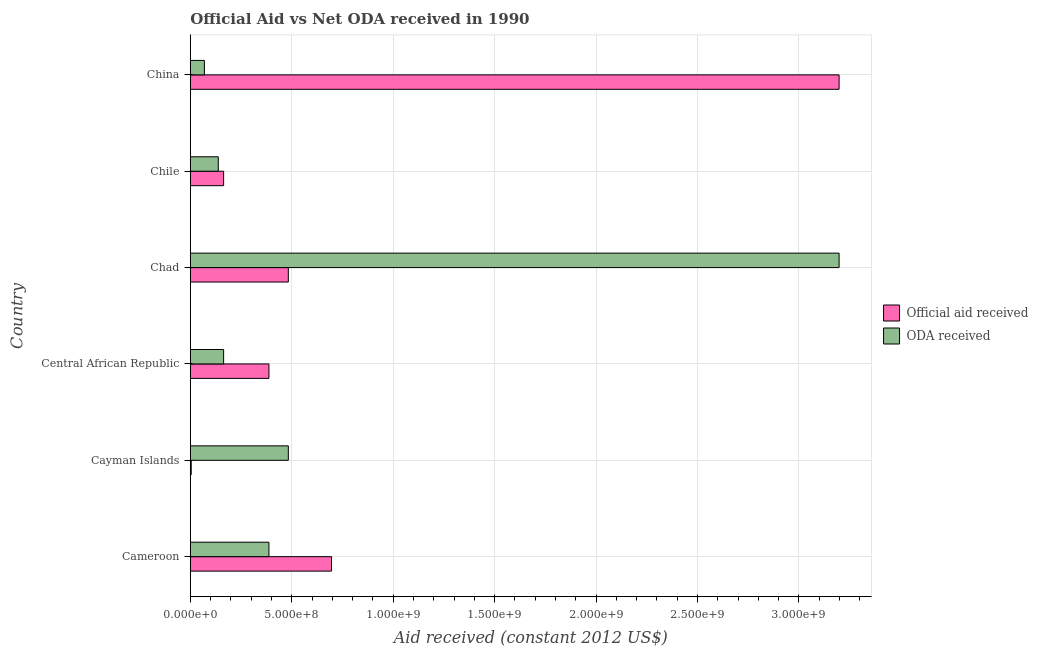Are the number of bars on each tick of the Y-axis equal?
Offer a very short reply. Yes. What is the label of the 5th group of bars from the top?
Your response must be concise. Cayman Islands. What is the official aid received in Cayman Islands?
Make the answer very short. 4.58e+06. Across all countries, what is the maximum oda received?
Your response must be concise. 3.20e+09. Across all countries, what is the minimum official aid received?
Ensure brevity in your answer.  4.58e+06. In which country was the official aid received minimum?
Keep it short and to the point. Cayman Islands. What is the total official aid received in the graph?
Ensure brevity in your answer.  4.93e+09. What is the difference between the official aid received in Cayman Islands and that in Chile?
Offer a very short reply. -1.60e+08. What is the average oda received per country?
Offer a terse response. 7.40e+08. What is the difference between the official aid received and oda received in Cameroon?
Ensure brevity in your answer.  3.09e+08. What is the ratio of the official aid received in Cameroon to that in Chad?
Offer a terse response. 1.44. Is the official aid received in Central African Republic less than that in Chad?
Keep it short and to the point. Yes. Is the difference between the oda received in Cameroon and Cayman Islands greater than the difference between the official aid received in Cameroon and Cayman Islands?
Ensure brevity in your answer.  No. What is the difference between the highest and the second highest official aid received?
Make the answer very short. 2.50e+09. What is the difference between the highest and the lowest official aid received?
Your response must be concise. 3.19e+09. Is the sum of the oda received in Central African Republic and Chad greater than the maximum official aid received across all countries?
Ensure brevity in your answer.  Yes. What does the 2nd bar from the top in Cayman Islands represents?
Keep it short and to the point. Official aid received. What does the 1st bar from the bottom in China represents?
Give a very brief answer. Official aid received. Are the values on the major ticks of X-axis written in scientific E-notation?
Your answer should be compact. Yes. Where does the legend appear in the graph?
Your answer should be compact. Center right. How are the legend labels stacked?
Keep it short and to the point. Vertical. What is the title of the graph?
Provide a short and direct response. Official Aid vs Net ODA received in 1990 . Does "Ages 15-24" appear as one of the legend labels in the graph?
Your response must be concise. No. What is the label or title of the X-axis?
Make the answer very short. Aid received (constant 2012 US$). What is the Aid received (constant 2012 US$) in Official aid received in Cameroon?
Ensure brevity in your answer.  6.96e+08. What is the Aid received (constant 2012 US$) of ODA received in Cameroon?
Provide a short and direct response. 3.88e+08. What is the Aid received (constant 2012 US$) in Official aid received in Cayman Islands?
Make the answer very short. 4.58e+06. What is the Aid received (constant 2012 US$) of ODA received in Cayman Islands?
Provide a short and direct response. 4.83e+08. What is the Aid received (constant 2012 US$) of Official aid received in Central African Republic?
Keep it short and to the point. 3.88e+08. What is the Aid received (constant 2012 US$) in ODA received in Central African Republic?
Ensure brevity in your answer.  1.64e+08. What is the Aid received (constant 2012 US$) in Official aid received in Chad?
Your answer should be very brief. 4.83e+08. What is the Aid received (constant 2012 US$) of ODA received in Chad?
Make the answer very short. 3.20e+09. What is the Aid received (constant 2012 US$) in Official aid received in Chile?
Your response must be concise. 1.64e+08. What is the Aid received (constant 2012 US$) of ODA received in Chile?
Offer a terse response. 1.38e+08. What is the Aid received (constant 2012 US$) of Official aid received in China?
Your response must be concise. 3.20e+09. What is the Aid received (constant 2012 US$) in ODA received in China?
Ensure brevity in your answer.  6.95e+07. Across all countries, what is the maximum Aid received (constant 2012 US$) in Official aid received?
Keep it short and to the point. 3.20e+09. Across all countries, what is the maximum Aid received (constant 2012 US$) of ODA received?
Your response must be concise. 3.20e+09. Across all countries, what is the minimum Aid received (constant 2012 US$) of Official aid received?
Provide a short and direct response. 4.58e+06. Across all countries, what is the minimum Aid received (constant 2012 US$) in ODA received?
Your answer should be very brief. 6.95e+07. What is the total Aid received (constant 2012 US$) in Official aid received in the graph?
Offer a very short reply. 4.93e+09. What is the total Aid received (constant 2012 US$) in ODA received in the graph?
Your response must be concise. 4.44e+09. What is the difference between the Aid received (constant 2012 US$) in Official aid received in Cameroon and that in Cayman Islands?
Ensure brevity in your answer.  6.92e+08. What is the difference between the Aid received (constant 2012 US$) in ODA received in Cameroon and that in Cayman Islands?
Your response must be concise. -9.55e+07. What is the difference between the Aid received (constant 2012 US$) in Official aid received in Cameroon and that in Central African Republic?
Your answer should be very brief. 3.09e+08. What is the difference between the Aid received (constant 2012 US$) of ODA received in Cameroon and that in Central African Republic?
Offer a very short reply. 2.23e+08. What is the difference between the Aid received (constant 2012 US$) in Official aid received in Cameroon and that in Chad?
Offer a very short reply. 2.13e+08. What is the difference between the Aid received (constant 2012 US$) in ODA received in Cameroon and that in Chad?
Your response must be concise. -2.81e+09. What is the difference between the Aid received (constant 2012 US$) in Official aid received in Cameroon and that in Chile?
Give a very brief answer. 5.32e+08. What is the difference between the Aid received (constant 2012 US$) of ODA received in Cameroon and that in Chile?
Offer a very short reply. 2.50e+08. What is the difference between the Aid received (constant 2012 US$) in Official aid received in Cameroon and that in China?
Your answer should be very brief. -2.50e+09. What is the difference between the Aid received (constant 2012 US$) in ODA received in Cameroon and that in China?
Your response must be concise. 3.18e+08. What is the difference between the Aid received (constant 2012 US$) in Official aid received in Cayman Islands and that in Central African Republic?
Ensure brevity in your answer.  -3.83e+08. What is the difference between the Aid received (constant 2012 US$) in ODA received in Cayman Islands and that in Central African Republic?
Your response must be concise. 3.19e+08. What is the difference between the Aid received (constant 2012 US$) of Official aid received in Cayman Islands and that in Chad?
Provide a short and direct response. -4.79e+08. What is the difference between the Aid received (constant 2012 US$) in ODA received in Cayman Islands and that in Chad?
Your answer should be compact. -2.72e+09. What is the difference between the Aid received (constant 2012 US$) in Official aid received in Cayman Islands and that in Chile?
Offer a terse response. -1.60e+08. What is the difference between the Aid received (constant 2012 US$) in ODA received in Cayman Islands and that in Chile?
Give a very brief answer. 3.45e+08. What is the difference between the Aid received (constant 2012 US$) in Official aid received in Cayman Islands and that in China?
Your response must be concise. -3.19e+09. What is the difference between the Aid received (constant 2012 US$) of ODA received in Cayman Islands and that in China?
Make the answer very short. 4.14e+08. What is the difference between the Aid received (constant 2012 US$) in Official aid received in Central African Republic and that in Chad?
Offer a terse response. -9.55e+07. What is the difference between the Aid received (constant 2012 US$) of ODA received in Central African Republic and that in Chad?
Give a very brief answer. -3.03e+09. What is the difference between the Aid received (constant 2012 US$) of Official aid received in Central African Republic and that in Chile?
Your response must be concise. 2.23e+08. What is the difference between the Aid received (constant 2012 US$) of ODA received in Central African Republic and that in Chile?
Ensure brevity in your answer.  2.64e+07. What is the difference between the Aid received (constant 2012 US$) in Official aid received in Central African Republic and that in China?
Ensure brevity in your answer.  -2.81e+09. What is the difference between the Aid received (constant 2012 US$) in ODA received in Central African Republic and that in China?
Ensure brevity in your answer.  9.48e+07. What is the difference between the Aid received (constant 2012 US$) of Official aid received in Chad and that in Chile?
Your answer should be very brief. 3.19e+08. What is the difference between the Aid received (constant 2012 US$) in ODA received in Chad and that in Chile?
Provide a short and direct response. 3.06e+09. What is the difference between the Aid received (constant 2012 US$) of Official aid received in Chad and that in China?
Your response must be concise. -2.72e+09. What is the difference between the Aid received (constant 2012 US$) of ODA received in Chad and that in China?
Ensure brevity in your answer.  3.13e+09. What is the difference between the Aid received (constant 2012 US$) of Official aid received in Chile and that in China?
Provide a succinct answer. -3.03e+09. What is the difference between the Aid received (constant 2012 US$) of ODA received in Chile and that in China?
Your response must be concise. 6.85e+07. What is the difference between the Aid received (constant 2012 US$) of Official aid received in Cameroon and the Aid received (constant 2012 US$) of ODA received in Cayman Islands?
Ensure brevity in your answer.  2.13e+08. What is the difference between the Aid received (constant 2012 US$) in Official aid received in Cameroon and the Aid received (constant 2012 US$) in ODA received in Central African Republic?
Offer a very short reply. 5.32e+08. What is the difference between the Aid received (constant 2012 US$) in Official aid received in Cameroon and the Aid received (constant 2012 US$) in ODA received in Chad?
Your answer should be compact. -2.50e+09. What is the difference between the Aid received (constant 2012 US$) in Official aid received in Cameroon and the Aid received (constant 2012 US$) in ODA received in Chile?
Your response must be concise. 5.58e+08. What is the difference between the Aid received (constant 2012 US$) in Official aid received in Cameroon and the Aid received (constant 2012 US$) in ODA received in China?
Keep it short and to the point. 6.27e+08. What is the difference between the Aid received (constant 2012 US$) in Official aid received in Cayman Islands and the Aid received (constant 2012 US$) in ODA received in Central African Republic?
Keep it short and to the point. -1.60e+08. What is the difference between the Aid received (constant 2012 US$) of Official aid received in Cayman Islands and the Aid received (constant 2012 US$) of ODA received in Chad?
Ensure brevity in your answer.  -3.19e+09. What is the difference between the Aid received (constant 2012 US$) of Official aid received in Cayman Islands and the Aid received (constant 2012 US$) of ODA received in Chile?
Make the answer very short. -1.33e+08. What is the difference between the Aid received (constant 2012 US$) in Official aid received in Cayman Islands and the Aid received (constant 2012 US$) in ODA received in China?
Keep it short and to the point. -6.49e+07. What is the difference between the Aid received (constant 2012 US$) in Official aid received in Central African Republic and the Aid received (constant 2012 US$) in ODA received in Chad?
Offer a very short reply. -2.81e+09. What is the difference between the Aid received (constant 2012 US$) of Official aid received in Central African Republic and the Aid received (constant 2012 US$) of ODA received in Chile?
Ensure brevity in your answer.  2.50e+08. What is the difference between the Aid received (constant 2012 US$) of Official aid received in Central African Republic and the Aid received (constant 2012 US$) of ODA received in China?
Your answer should be very brief. 3.18e+08. What is the difference between the Aid received (constant 2012 US$) of Official aid received in Chad and the Aid received (constant 2012 US$) of ODA received in Chile?
Offer a terse response. 3.45e+08. What is the difference between the Aid received (constant 2012 US$) in Official aid received in Chad and the Aid received (constant 2012 US$) in ODA received in China?
Your answer should be very brief. 4.14e+08. What is the difference between the Aid received (constant 2012 US$) of Official aid received in Chile and the Aid received (constant 2012 US$) of ODA received in China?
Offer a very short reply. 9.48e+07. What is the average Aid received (constant 2012 US$) of Official aid received per country?
Keep it short and to the point. 8.22e+08. What is the average Aid received (constant 2012 US$) in ODA received per country?
Your answer should be very brief. 7.40e+08. What is the difference between the Aid received (constant 2012 US$) in Official aid received and Aid received (constant 2012 US$) in ODA received in Cameroon?
Offer a very short reply. 3.09e+08. What is the difference between the Aid received (constant 2012 US$) of Official aid received and Aid received (constant 2012 US$) of ODA received in Cayman Islands?
Offer a very short reply. -4.79e+08. What is the difference between the Aid received (constant 2012 US$) in Official aid received and Aid received (constant 2012 US$) in ODA received in Central African Republic?
Ensure brevity in your answer.  2.23e+08. What is the difference between the Aid received (constant 2012 US$) in Official aid received and Aid received (constant 2012 US$) in ODA received in Chad?
Your response must be concise. -2.72e+09. What is the difference between the Aid received (constant 2012 US$) in Official aid received and Aid received (constant 2012 US$) in ODA received in Chile?
Offer a very short reply. 2.64e+07. What is the difference between the Aid received (constant 2012 US$) of Official aid received and Aid received (constant 2012 US$) of ODA received in China?
Provide a short and direct response. 3.13e+09. What is the ratio of the Aid received (constant 2012 US$) in Official aid received in Cameroon to that in Cayman Islands?
Ensure brevity in your answer.  152.01. What is the ratio of the Aid received (constant 2012 US$) in ODA received in Cameroon to that in Cayman Islands?
Ensure brevity in your answer.  0.8. What is the ratio of the Aid received (constant 2012 US$) in Official aid received in Cameroon to that in Central African Republic?
Your answer should be very brief. 1.8. What is the ratio of the Aid received (constant 2012 US$) of ODA received in Cameroon to that in Central African Republic?
Provide a succinct answer. 2.36. What is the ratio of the Aid received (constant 2012 US$) of Official aid received in Cameroon to that in Chad?
Your answer should be compact. 1.44. What is the ratio of the Aid received (constant 2012 US$) of ODA received in Cameroon to that in Chad?
Offer a terse response. 0.12. What is the ratio of the Aid received (constant 2012 US$) of Official aid received in Cameroon to that in Chile?
Provide a short and direct response. 4.24. What is the ratio of the Aid received (constant 2012 US$) of ODA received in Cameroon to that in Chile?
Keep it short and to the point. 2.81. What is the ratio of the Aid received (constant 2012 US$) in Official aid received in Cameroon to that in China?
Keep it short and to the point. 0.22. What is the ratio of the Aid received (constant 2012 US$) of ODA received in Cameroon to that in China?
Provide a short and direct response. 5.58. What is the ratio of the Aid received (constant 2012 US$) in Official aid received in Cayman Islands to that in Central African Republic?
Provide a short and direct response. 0.01. What is the ratio of the Aid received (constant 2012 US$) of ODA received in Cayman Islands to that in Central African Republic?
Your response must be concise. 2.94. What is the ratio of the Aid received (constant 2012 US$) of Official aid received in Cayman Islands to that in Chad?
Offer a terse response. 0.01. What is the ratio of the Aid received (constant 2012 US$) in ODA received in Cayman Islands to that in Chad?
Offer a very short reply. 0.15. What is the ratio of the Aid received (constant 2012 US$) in Official aid received in Cayman Islands to that in Chile?
Your answer should be compact. 0.03. What is the ratio of the Aid received (constant 2012 US$) in ODA received in Cayman Islands to that in Chile?
Give a very brief answer. 3.5. What is the ratio of the Aid received (constant 2012 US$) of Official aid received in Cayman Islands to that in China?
Offer a very short reply. 0. What is the ratio of the Aid received (constant 2012 US$) in ODA received in Cayman Islands to that in China?
Provide a short and direct response. 6.95. What is the ratio of the Aid received (constant 2012 US$) in Official aid received in Central African Republic to that in Chad?
Provide a short and direct response. 0.8. What is the ratio of the Aid received (constant 2012 US$) of ODA received in Central African Republic to that in Chad?
Ensure brevity in your answer.  0.05. What is the ratio of the Aid received (constant 2012 US$) in Official aid received in Central African Republic to that in Chile?
Give a very brief answer. 2.36. What is the ratio of the Aid received (constant 2012 US$) of ODA received in Central African Republic to that in Chile?
Your answer should be very brief. 1.19. What is the ratio of the Aid received (constant 2012 US$) in Official aid received in Central African Republic to that in China?
Your answer should be compact. 0.12. What is the ratio of the Aid received (constant 2012 US$) in ODA received in Central African Republic to that in China?
Offer a very short reply. 2.36. What is the ratio of the Aid received (constant 2012 US$) in Official aid received in Chad to that in Chile?
Offer a terse response. 2.94. What is the ratio of the Aid received (constant 2012 US$) in ODA received in Chad to that in Chile?
Provide a short and direct response. 23.18. What is the ratio of the Aid received (constant 2012 US$) in Official aid received in Chad to that in China?
Offer a very short reply. 0.15. What is the ratio of the Aid received (constant 2012 US$) in ODA received in Chad to that in China?
Provide a short and direct response. 46.01. What is the ratio of the Aid received (constant 2012 US$) of Official aid received in Chile to that in China?
Offer a terse response. 0.05. What is the ratio of the Aid received (constant 2012 US$) of ODA received in Chile to that in China?
Keep it short and to the point. 1.99. What is the difference between the highest and the second highest Aid received (constant 2012 US$) of Official aid received?
Offer a terse response. 2.50e+09. What is the difference between the highest and the second highest Aid received (constant 2012 US$) in ODA received?
Provide a succinct answer. 2.72e+09. What is the difference between the highest and the lowest Aid received (constant 2012 US$) in Official aid received?
Your answer should be compact. 3.19e+09. What is the difference between the highest and the lowest Aid received (constant 2012 US$) in ODA received?
Provide a short and direct response. 3.13e+09. 